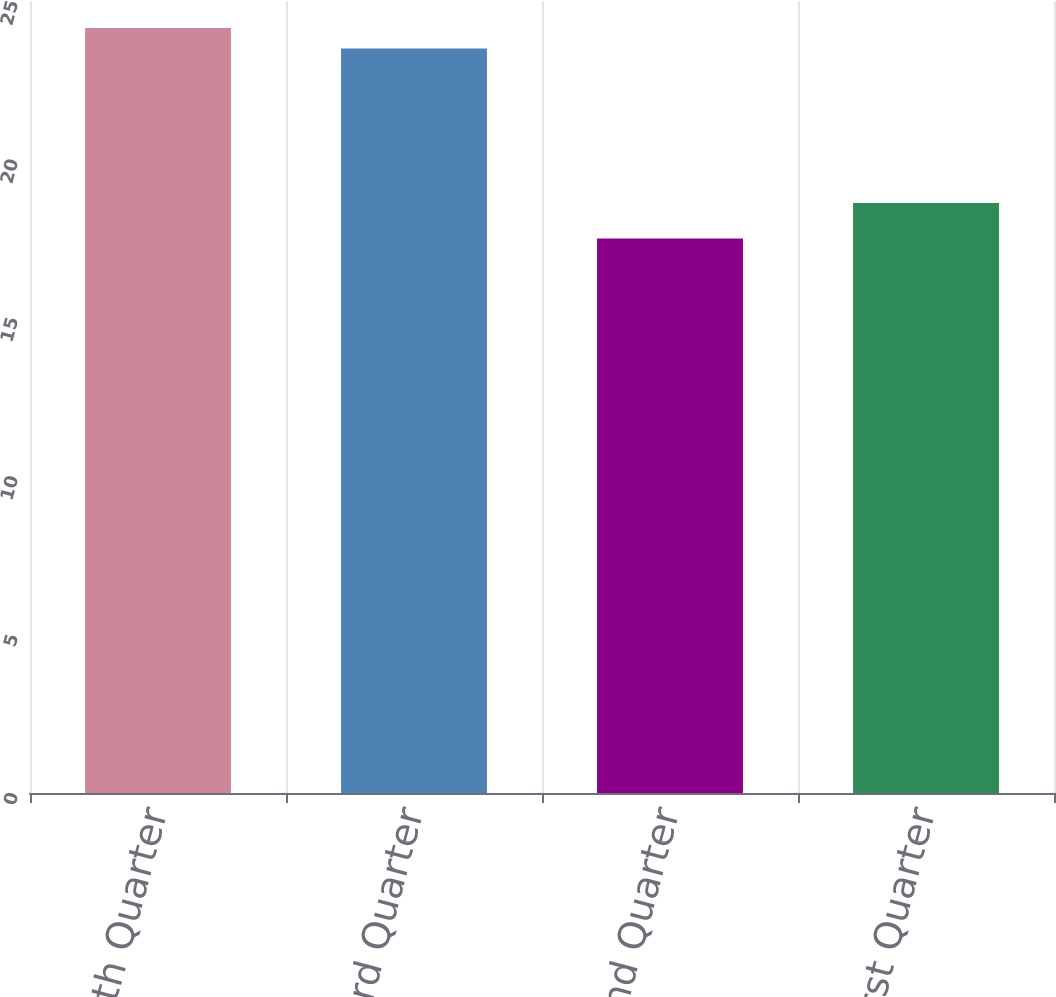<chart> <loc_0><loc_0><loc_500><loc_500><bar_chart><fcel>Fourth Quarter<fcel>Third Quarter<fcel>Second Quarter<fcel>First Quarter<nl><fcel>24.15<fcel>23.5<fcel>17.5<fcel>18.62<nl></chart> 